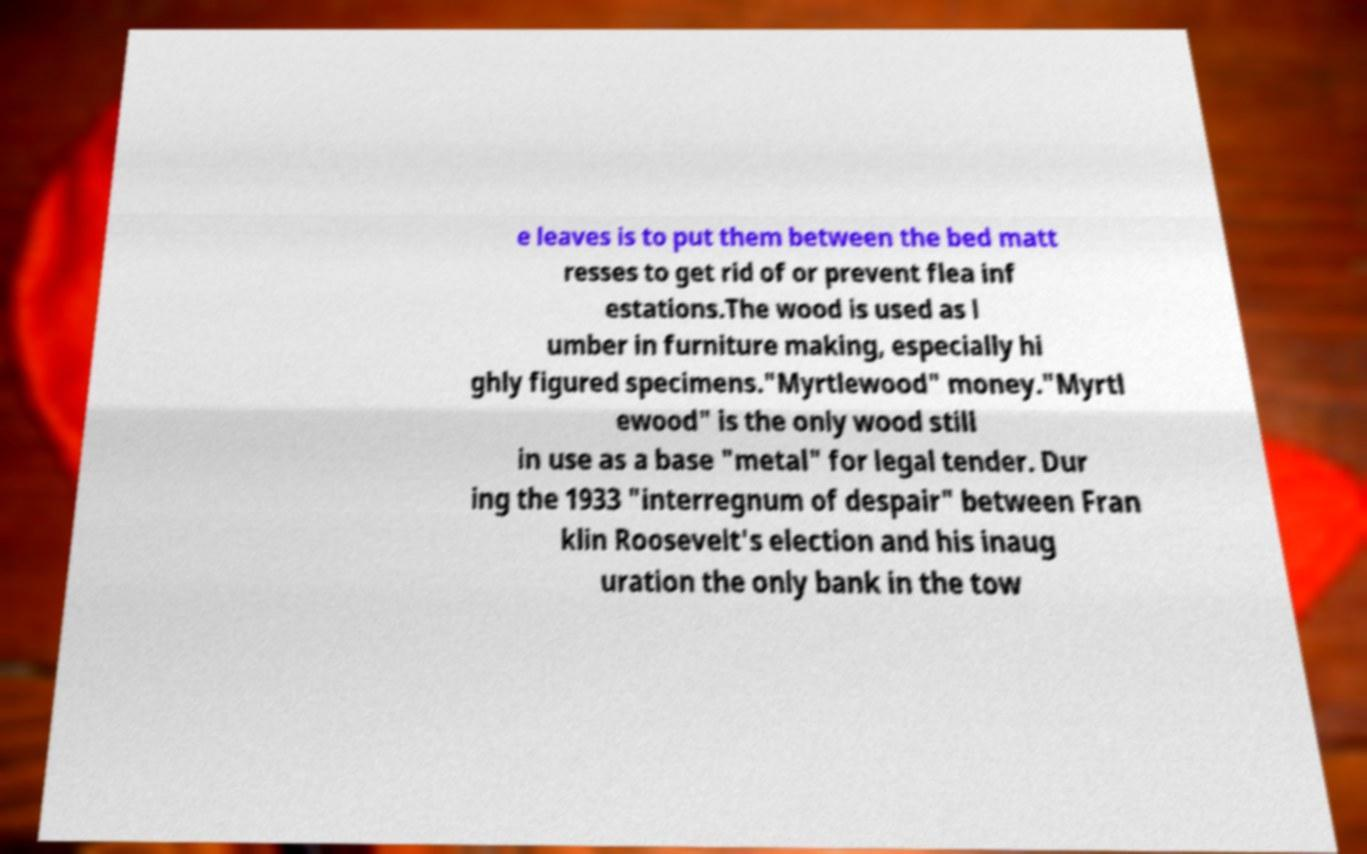Could you assist in decoding the text presented in this image and type it out clearly? e leaves is to put them between the bed matt resses to get rid of or prevent flea inf estations.The wood is used as l umber in furniture making, especially hi ghly figured specimens."Myrtlewood" money."Myrtl ewood" is the only wood still in use as a base "metal" for legal tender. Dur ing the 1933 "interregnum of despair" between Fran klin Roosevelt's election and his inaug uration the only bank in the tow 